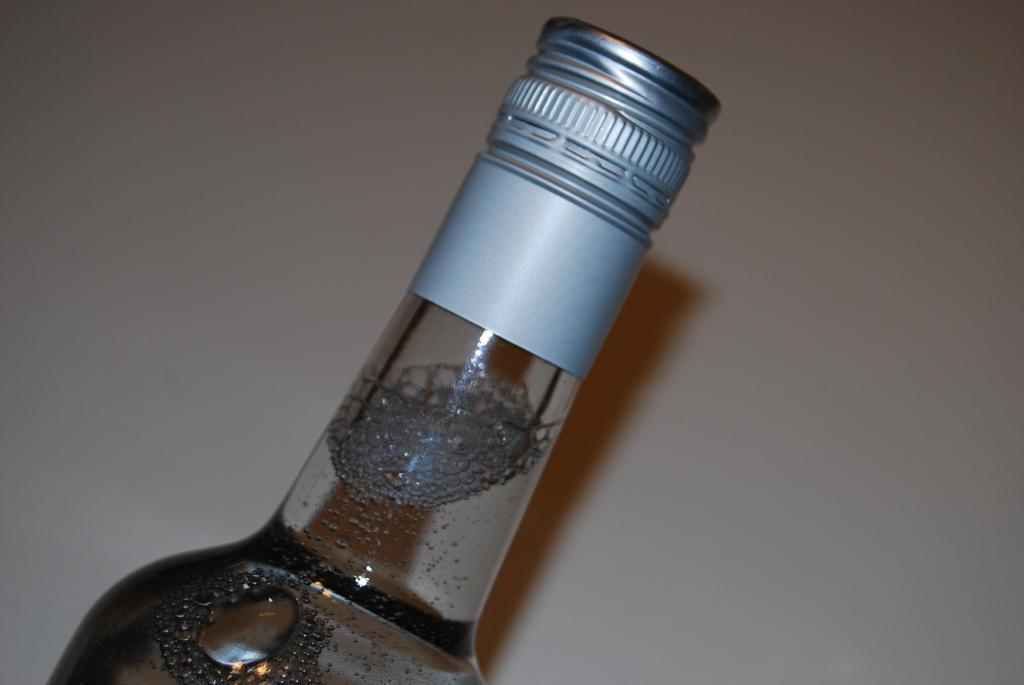How would you summarize this image in a sentence or two? This is a glass bottle which is sealed with a silver metal cap. There is some liquid inside the bottle. 